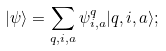<formula> <loc_0><loc_0><loc_500><loc_500>| \psi \rangle = \sum _ { q , i , a } \psi ^ { q } _ { i , a } | q , i , a \rangle ;</formula> 